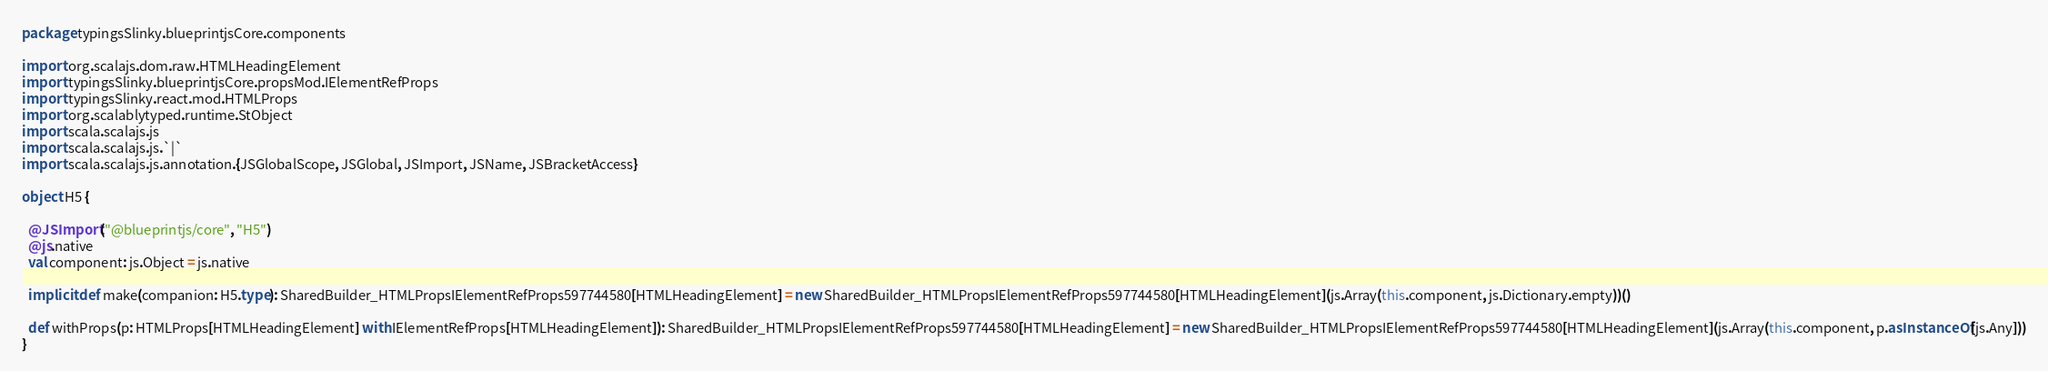<code> <loc_0><loc_0><loc_500><loc_500><_Scala_>package typingsSlinky.blueprintjsCore.components

import org.scalajs.dom.raw.HTMLHeadingElement
import typingsSlinky.blueprintjsCore.propsMod.IElementRefProps
import typingsSlinky.react.mod.HTMLProps
import org.scalablytyped.runtime.StObject
import scala.scalajs.js
import scala.scalajs.js.`|`
import scala.scalajs.js.annotation.{JSGlobalScope, JSGlobal, JSImport, JSName, JSBracketAccess}

object H5 {
  
  @JSImport("@blueprintjs/core", "H5")
  @js.native
  val component: js.Object = js.native
  
  implicit def make(companion: H5.type): SharedBuilder_HTMLPropsIElementRefProps597744580[HTMLHeadingElement] = new SharedBuilder_HTMLPropsIElementRefProps597744580[HTMLHeadingElement](js.Array(this.component, js.Dictionary.empty))()
  
  def withProps(p: HTMLProps[HTMLHeadingElement] with IElementRefProps[HTMLHeadingElement]): SharedBuilder_HTMLPropsIElementRefProps597744580[HTMLHeadingElement] = new SharedBuilder_HTMLPropsIElementRefProps597744580[HTMLHeadingElement](js.Array(this.component, p.asInstanceOf[js.Any]))
}
</code> 